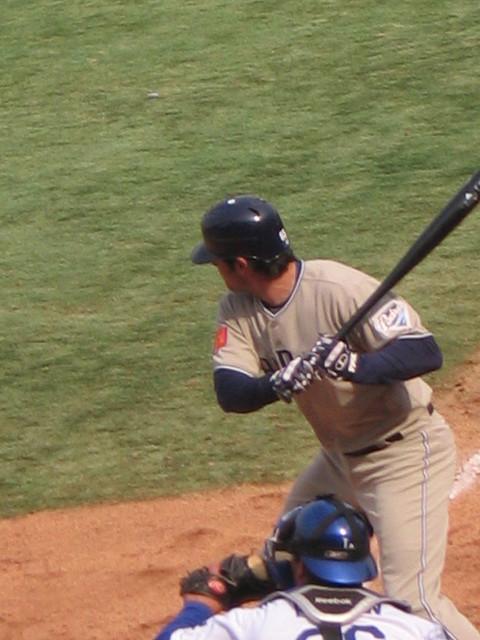What color is the bat?
Quick response, please. Black. Is this a professional baseball game?
Quick response, please. Yes. Is the batter wearing a nice color?
Quick response, please. Yes. 